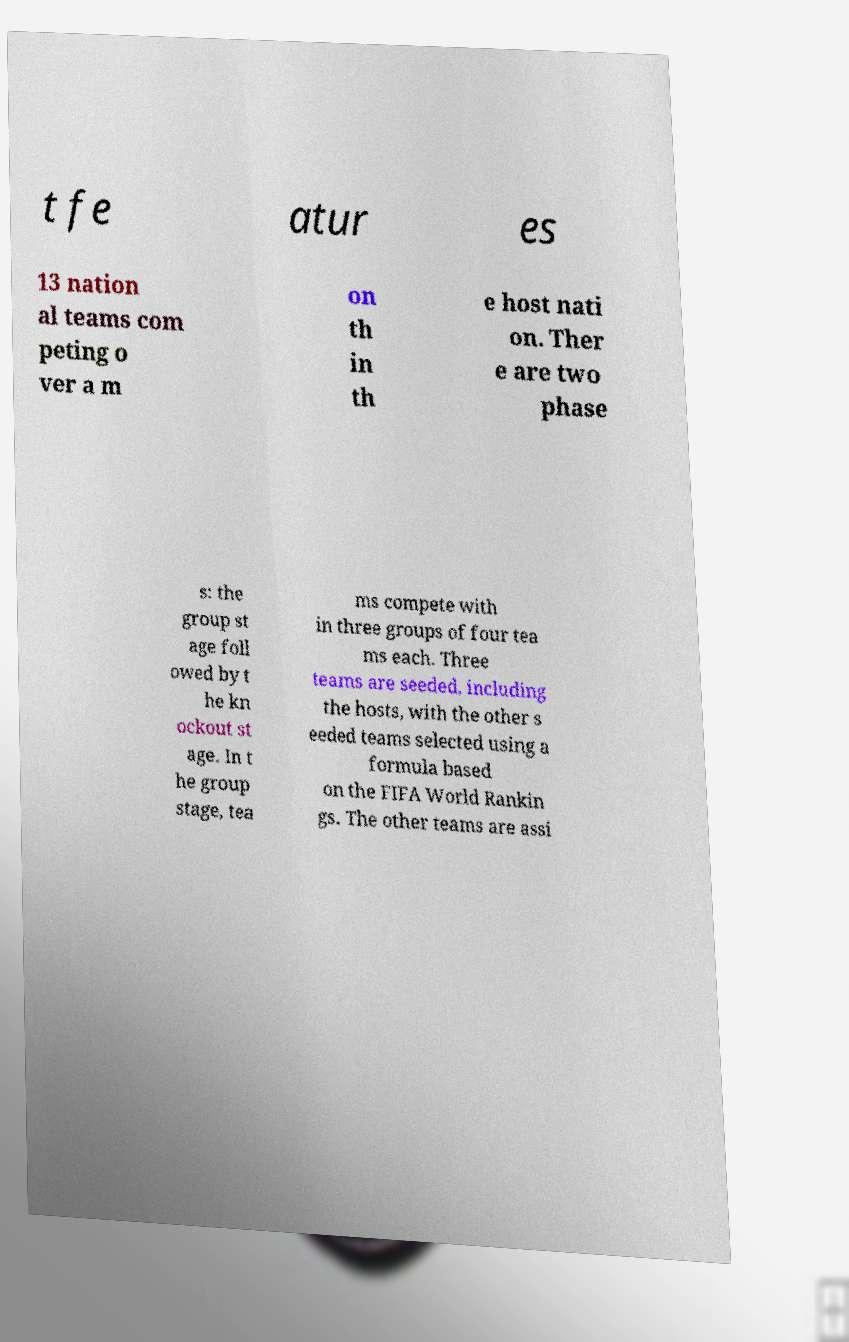I need the written content from this picture converted into text. Can you do that? t fe atur es 13 nation al teams com peting o ver a m on th in th e host nati on. Ther e are two phase s: the group st age foll owed by t he kn ockout st age. In t he group stage, tea ms compete with in three groups of four tea ms each. Three teams are seeded, including the hosts, with the other s eeded teams selected using a formula based on the FIFA World Rankin gs. The other teams are assi 